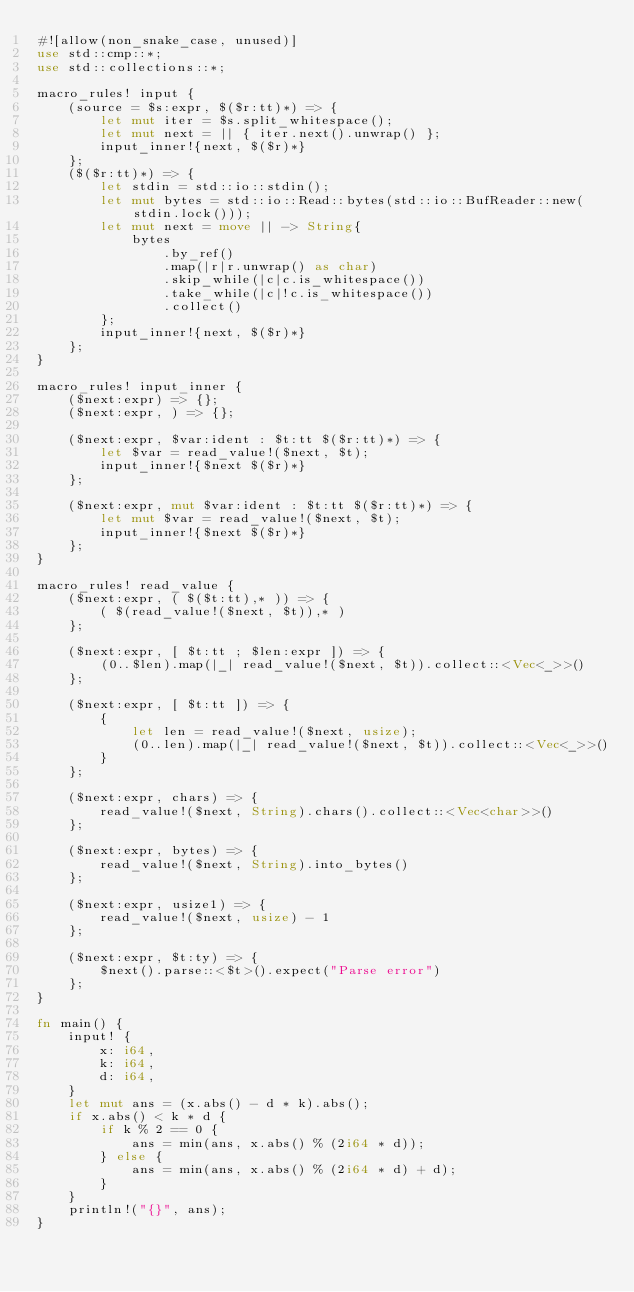Convert code to text. <code><loc_0><loc_0><loc_500><loc_500><_Rust_>#![allow(non_snake_case, unused)]
use std::cmp::*;
use std::collections::*;

macro_rules! input {
    (source = $s:expr, $($r:tt)*) => {
        let mut iter = $s.split_whitespace();
        let mut next = || { iter.next().unwrap() };
        input_inner!{next, $($r)*}
    };
    ($($r:tt)*) => {
        let stdin = std::io::stdin();
        let mut bytes = std::io::Read::bytes(std::io::BufReader::new(stdin.lock()));
        let mut next = move || -> String{
            bytes
                .by_ref()
                .map(|r|r.unwrap() as char)
                .skip_while(|c|c.is_whitespace())
                .take_while(|c|!c.is_whitespace())
                .collect()
        };
        input_inner!{next, $($r)*}
    };
}

macro_rules! input_inner {
    ($next:expr) => {};
    ($next:expr, ) => {};

    ($next:expr, $var:ident : $t:tt $($r:tt)*) => {
        let $var = read_value!($next, $t);
        input_inner!{$next $($r)*}
    };

    ($next:expr, mut $var:ident : $t:tt $($r:tt)*) => {
        let mut $var = read_value!($next, $t);
        input_inner!{$next $($r)*}
    };
}

macro_rules! read_value {
    ($next:expr, ( $($t:tt),* )) => {
        ( $(read_value!($next, $t)),* )
    };

    ($next:expr, [ $t:tt ; $len:expr ]) => {
        (0..$len).map(|_| read_value!($next, $t)).collect::<Vec<_>>()
    };

    ($next:expr, [ $t:tt ]) => {
        {
            let len = read_value!($next, usize);
            (0..len).map(|_| read_value!($next, $t)).collect::<Vec<_>>()
        }
    };

    ($next:expr, chars) => {
        read_value!($next, String).chars().collect::<Vec<char>>()
    };

    ($next:expr, bytes) => {
        read_value!($next, String).into_bytes()
    };

    ($next:expr, usize1) => {
        read_value!($next, usize) - 1
    };

    ($next:expr, $t:ty) => {
        $next().parse::<$t>().expect("Parse error")
    };
}

fn main() {
    input! {
        x: i64,
        k: i64,
        d: i64,
    }
    let mut ans = (x.abs() - d * k).abs();
    if x.abs() < k * d {
        if k % 2 == 0 {
            ans = min(ans, x.abs() % (2i64 * d));
        } else {
            ans = min(ans, x.abs() % (2i64 * d) + d);
        }
    }
    println!("{}", ans);
}
</code> 